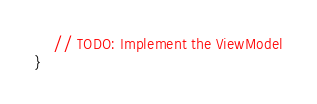<code> <loc_0><loc_0><loc_500><loc_500><_Kotlin_>    // TODO: Implement the ViewModel
}</code> 